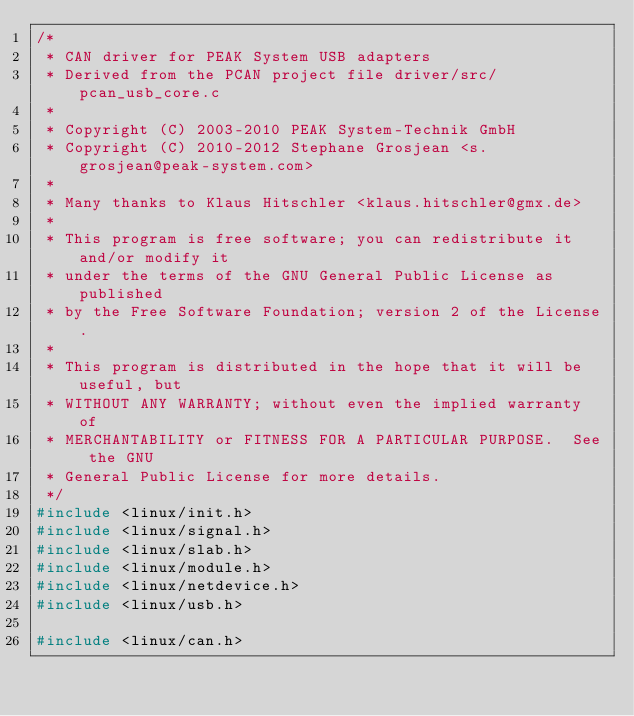Convert code to text. <code><loc_0><loc_0><loc_500><loc_500><_C_>/*
 * CAN driver for PEAK System USB adapters
 * Derived from the PCAN project file driver/src/pcan_usb_core.c
 *
 * Copyright (C) 2003-2010 PEAK System-Technik GmbH
 * Copyright (C) 2010-2012 Stephane Grosjean <s.grosjean@peak-system.com>
 *
 * Many thanks to Klaus Hitschler <klaus.hitschler@gmx.de>
 *
 * This program is free software; you can redistribute it and/or modify it
 * under the terms of the GNU General Public License as published
 * by the Free Software Foundation; version 2 of the License.
 *
 * This program is distributed in the hope that it will be useful, but
 * WITHOUT ANY WARRANTY; without even the implied warranty of
 * MERCHANTABILITY or FITNESS FOR A PARTICULAR PURPOSE.  See the GNU
 * General Public License for more details.
 */
#include <linux/init.h>
#include <linux/signal.h>
#include <linux/slab.h>
#include <linux/module.h>
#include <linux/netdevice.h>
#include <linux/usb.h>

#include <linux/can.h></code> 